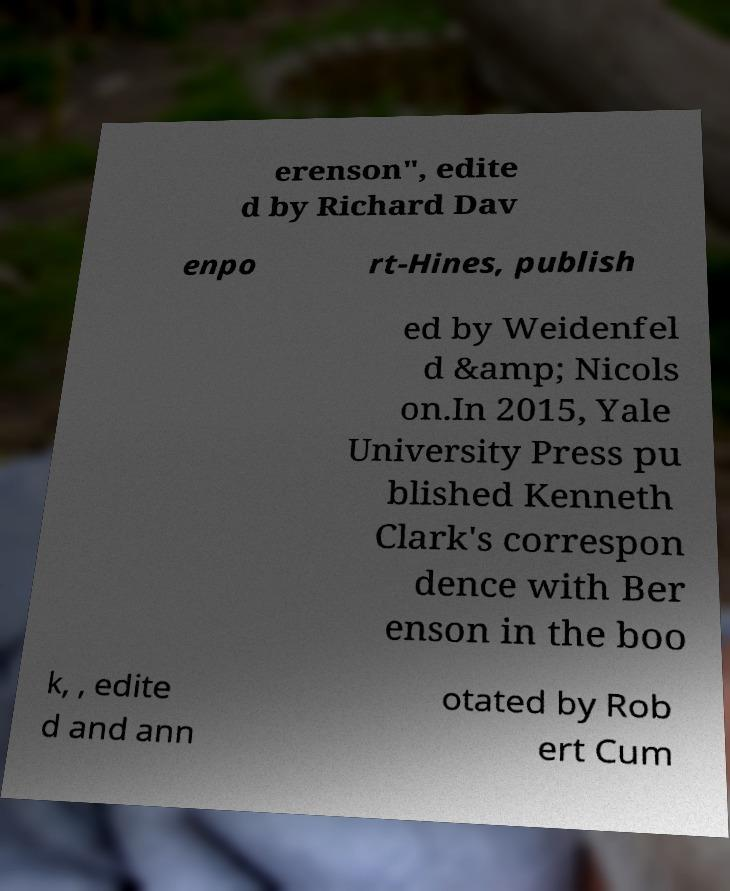There's text embedded in this image that I need extracted. Can you transcribe it verbatim? erenson", edite d by Richard Dav enpo rt-Hines, publish ed by Weidenfel d &amp; Nicols on.In 2015, Yale University Press pu blished Kenneth Clark's correspon dence with Ber enson in the boo k, , edite d and ann otated by Rob ert Cum 